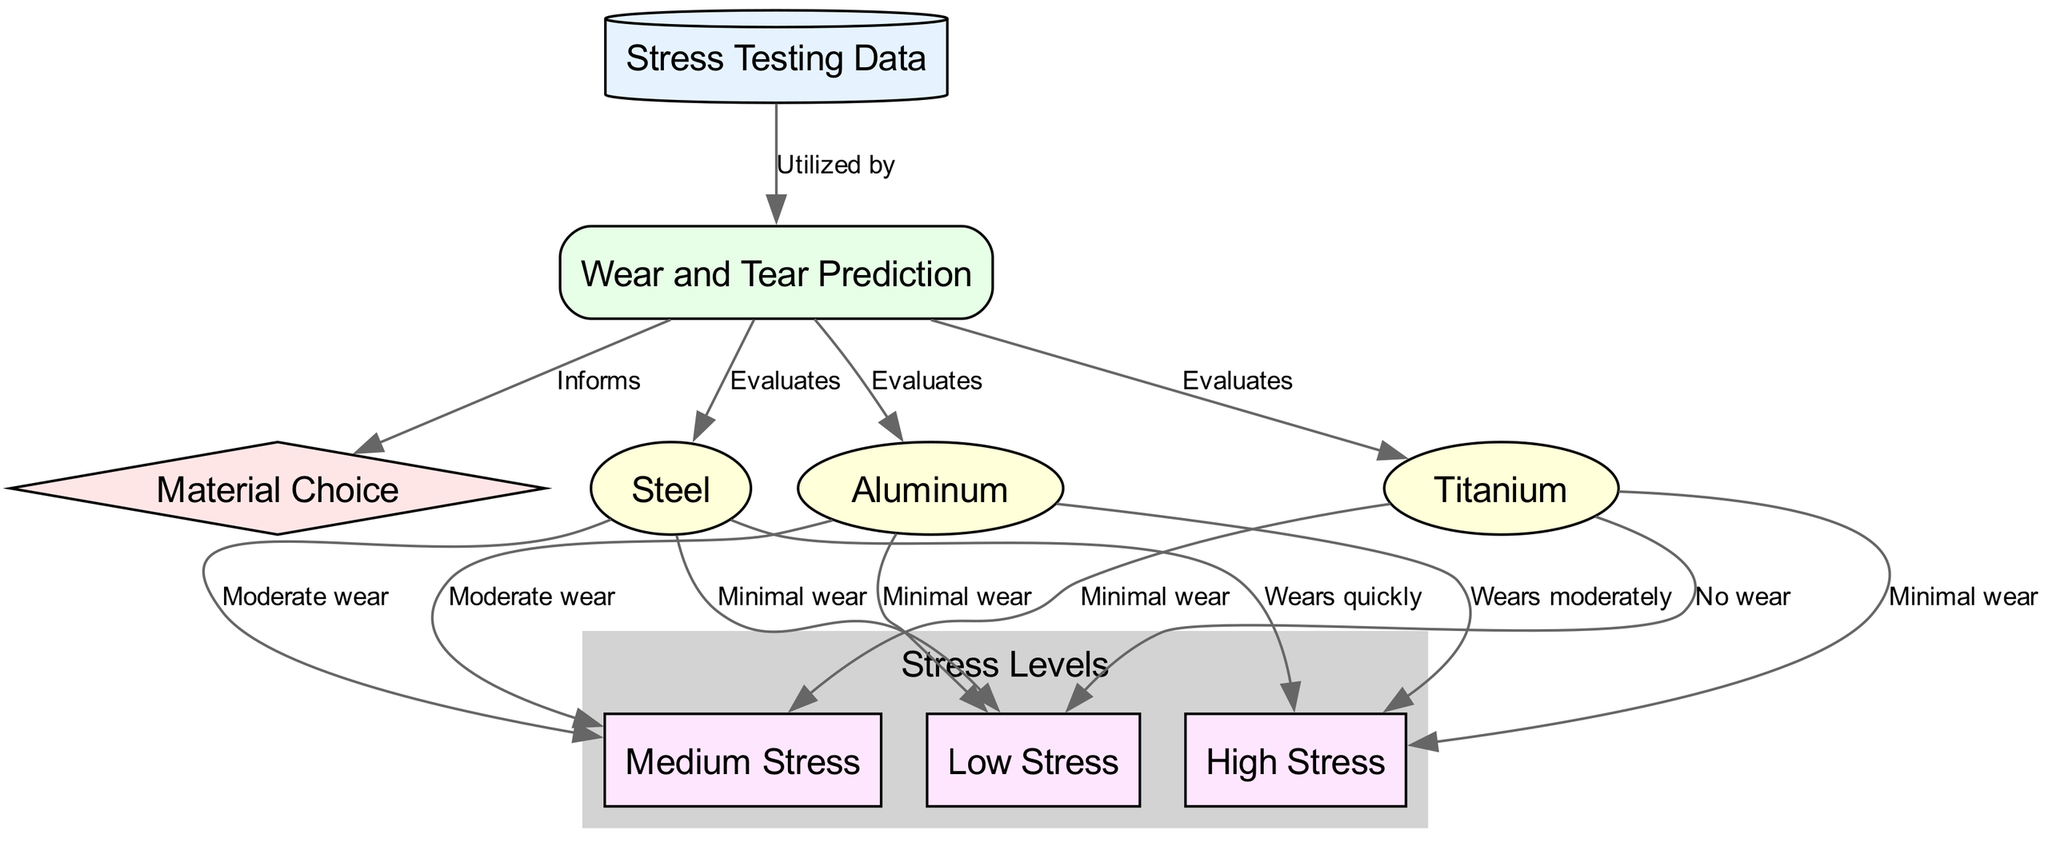What is the starting point of the flow in the diagram? The starting point of the flow is the "Stress Testing Data" node, which is the first node that contributes to the wear and tear predictions.
Answer: Stress Testing Data How many materials are evaluated in the wear and tear predictions? The diagram shows three materials being evaluated: Steel, Aluminum, and Titanium.
Answer: Three What type of relationship does "Wear and Tear Prediction" have with "Material Choice"? The relationship is that the "Wear and Tear Prediction" informs the "Material Choice," indicating a directional flow of information.
Answer: Informs What does "Steel" experience under high stress according to the diagram? Under high stress, "Steel" wears quickly, which is specified as a direct outcome of that condition.
Answer: Wears quickly Which material shows minimal wear under low stress conditions? "Titanium" shows no wear under low stress conditions, while "Aluminum" also has minimal wear, but it is "Titanium" that qualifies as minimal wear with a more favorable condition.
Answer: Minimal wear Which material has the highest wear level under high stress? "Steel" has the highest wear level under high stress, as it specifically indicates it wears quickly.
Answer: Wears quickly If the stress level is medium, which material shows moderate wear? Both "Steel" and "Aluminum" show moderate wear under medium stress, but the context of the question refers to the specific evaluation.
Answer: Moderate wear Explain the evaluation process for Titanium under stress levels. The "Wear and Tear Prediction" evaluates "Titanium" under all three stress levels: it shows minimal wear for high and medium stress, and no wear for low stress, indicating a strong performance across conditions.
Answer: Minimal wear How does "Stress Testing Data" contribute to the diagram? The "Stress Testing Data" is utilized by the "Wear and Tear Prediction," serving as the foundational data that drives subsequent predictions for material performance under various stress levels.
Answer: Utilized by 